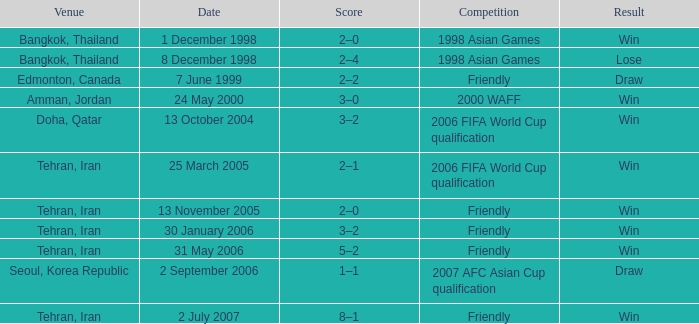What was the competition on 13 November 2005? Friendly. 